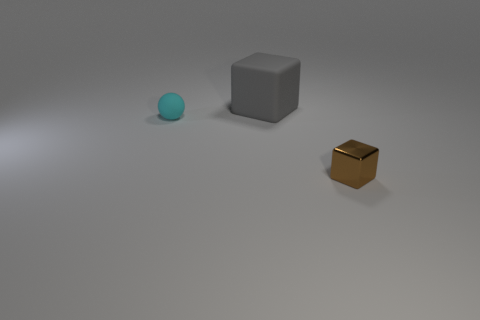Add 3 gray matte objects. How many objects exist? 6 Subtract all cubes. How many objects are left? 1 Add 1 tiny rubber spheres. How many tiny rubber spheres are left? 2 Add 2 big matte things. How many big matte things exist? 3 Subtract 0 purple cylinders. How many objects are left? 3 Subtract all small cyan matte cubes. Subtract all big blocks. How many objects are left? 2 